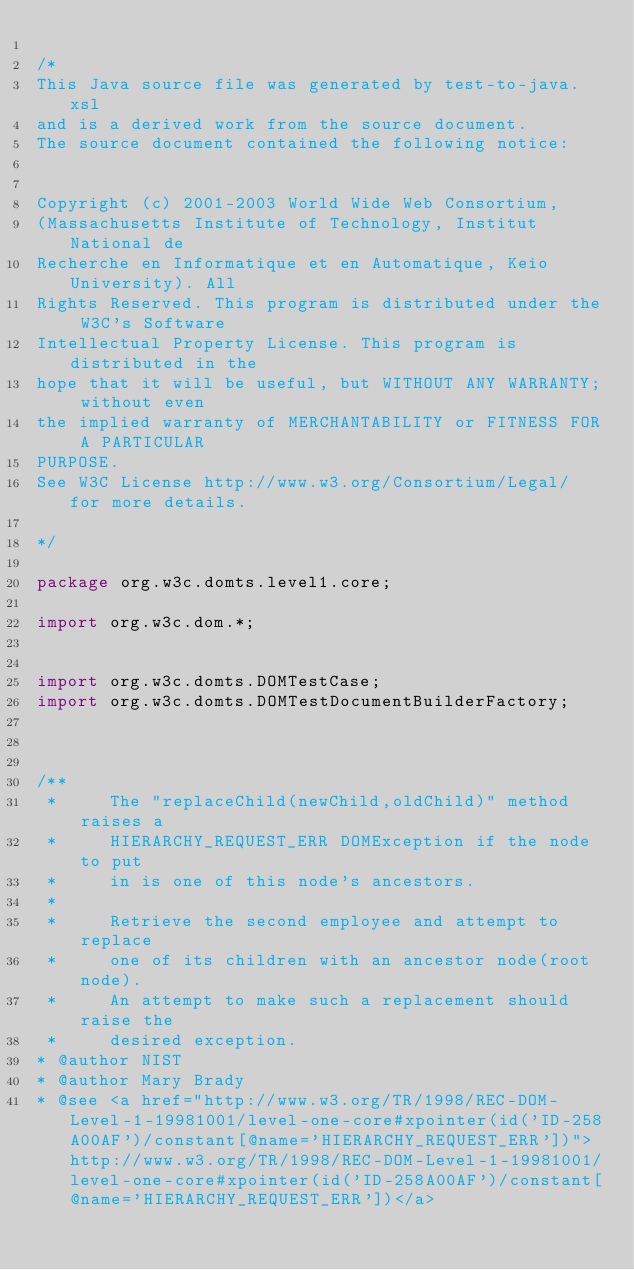<code> <loc_0><loc_0><loc_500><loc_500><_Java_>
/*
This Java source file was generated by test-to-java.xsl
and is a derived work from the source document.
The source document contained the following notice:


Copyright (c) 2001-2003 World Wide Web Consortium,
(Massachusetts Institute of Technology, Institut National de
Recherche en Informatique et en Automatique, Keio University). All
Rights Reserved. This program is distributed under the W3C's Software
Intellectual Property License. This program is distributed in the
hope that it will be useful, but WITHOUT ANY WARRANTY; without even
the implied warranty of MERCHANTABILITY or FITNESS FOR A PARTICULAR
PURPOSE.
See W3C License http://www.w3.org/Consortium/Legal/ for more details.

*/

package org.w3c.domts.level1.core;

import org.w3c.dom.*;


import org.w3c.domts.DOMTestCase;
import org.w3c.domts.DOMTestDocumentBuilderFactory;



/**
 *     The "replaceChild(newChild,oldChild)" method raises a 
 *     HIERARCHY_REQUEST_ERR DOMException if the node to put
 *     in is one of this node's ancestors.
 *     
 *     Retrieve the second employee and attempt to replace
 *     one of its children with an ancestor node(root node).
 *     An attempt to make such a replacement should raise the 
 *     desired exception.
* @author NIST
* @author Mary Brady
* @see <a href="http://www.w3.org/TR/1998/REC-DOM-Level-1-19981001/level-one-core#xpointer(id('ID-258A00AF')/constant[@name='HIERARCHY_REQUEST_ERR'])">http://www.w3.org/TR/1998/REC-DOM-Level-1-19981001/level-one-core#xpointer(id('ID-258A00AF')/constant[@name='HIERARCHY_REQUEST_ERR'])</a></code> 